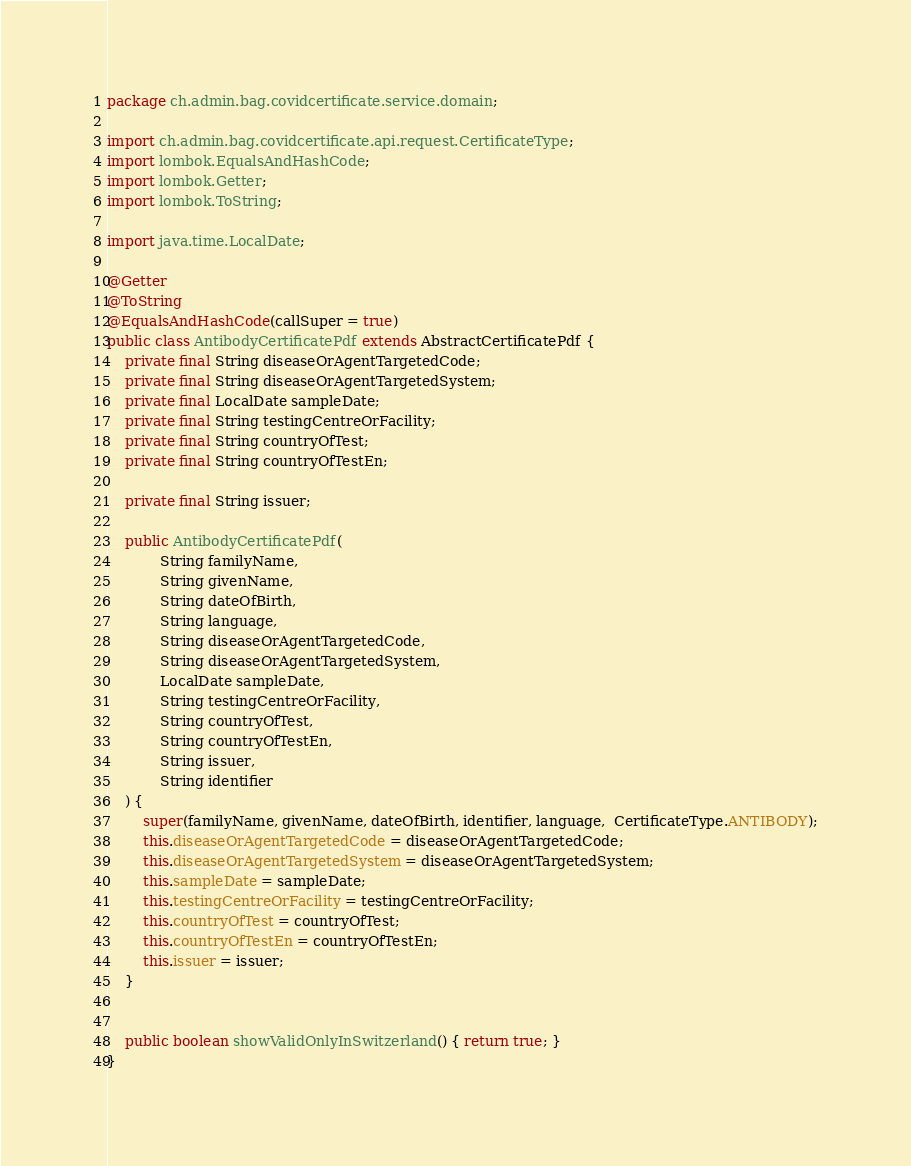<code> <loc_0><loc_0><loc_500><loc_500><_Java_>package ch.admin.bag.covidcertificate.service.domain;

import ch.admin.bag.covidcertificate.api.request.CertificateType;
import lombok.EqualsAndHashCode;
import lombok.Getter;
import lombok.ToString;

import java.time.LocalDate;

@Getter
@ToString
@EqualsAndHashCode(callSuper = true)
public class AntibodyCertificatePdf extends AbstractCertificatePdf {
    private final String diseaseOrAgentTargetedCode;
    private final String diseaseOrAgentTargetedSystem;
    private final LocalDate sampleDate;
    private final String testingCentreOrFacility;
    private final String countryOfTest;
    private final String countryOfTestEn;

    private final String issuer;

    public AntibodyCertificatePdf(
            String familyName,
            String givenName,
            String dateOfBirth,
            String language,
            String diseaseOrAgentTargetedCode,
            String diseaseOrAgentTargetedSystem,
            LocalDate sampleDate,
            String testingCentreOrFacility,
            String countryOfTest,
            String countryOfTestEn,
            String issuer,
            String identifier
    ) {
        super(familyName, givenName, dateOfBirth, identifier, language,  CertificateType.ANTIBODY);
        this.diseaseOrAgentTargetedCode = diseaseOrAgentTargetedCode;
        this.diseaseOrAgentTargetedSystem = diseaseOrAgentTargetedSystem;
        this.sampleDate = sampleDate;
        this.testingCentreOrFacility = testingCentreOrFacility;
        this.countryOfTest = countryOfTest;
        this.countryOfTestEn = countryOfTestEn;
        this.issuer = issuer;
    }


    public boolean showValidOnlyInSwitzerland() { return true; }
}
</code> 